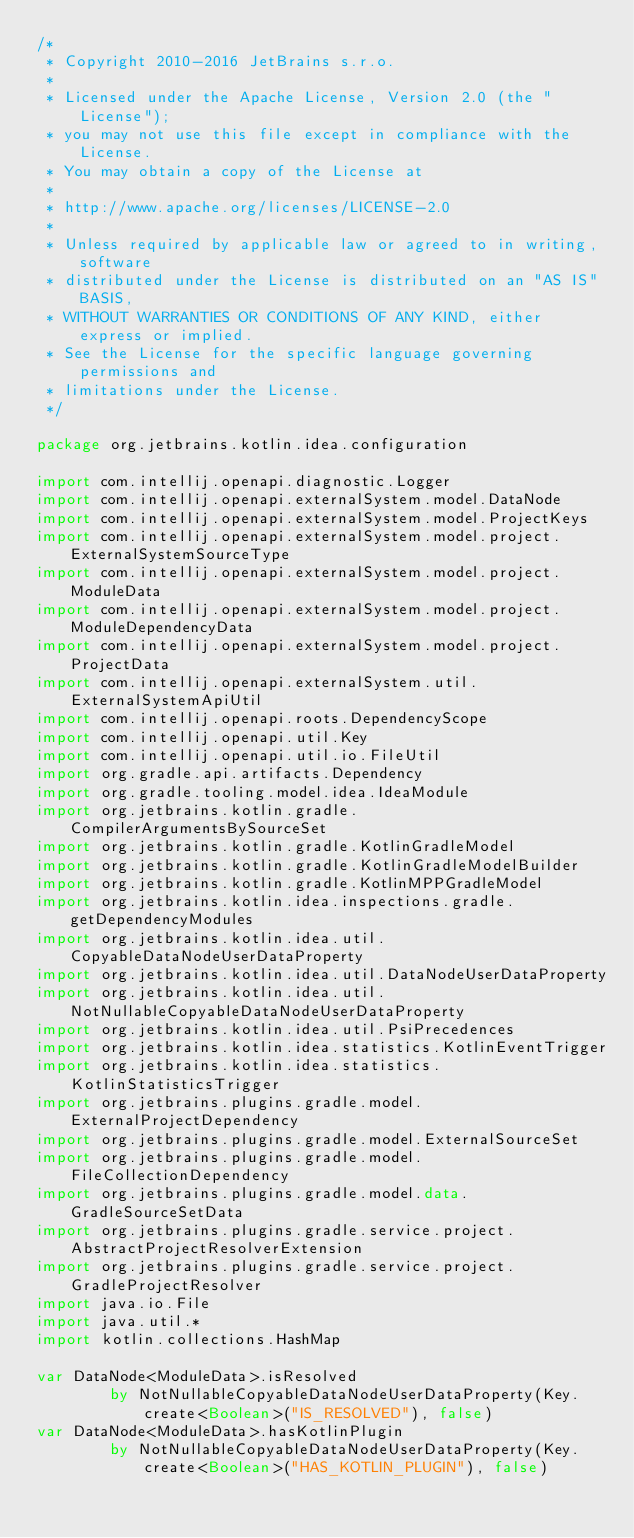Convert code to text. <code><loc_0><loc_0><loc_500><loc_500><_Kotlin_>/*
 * Copyright 2010-2016 JetBrains s.r.o.
 *
 * Licensed under the Apache License, Version 2.0 (the "License");
 * you may not use this file except in compliance with the License.
 * You may obtain a copy of the License at
 *
 * http://www.apache.org/licenses/LICENSE-2.0
 *
 * Unless required by applicable law or agreed to in writing, software
 * distributed under the License is distributed on an "AS IS" BASIS,
 * WITHOUT WARRANTIES OR CONDITIONS OF ANY KIND, either express or implied.
 * See the License for the specific language governing permissions and
 * limitations under the License.
 */

package org.jetbrains.kotlin.idea.configuration

import com.intellij.openapi.diagnostic.Logger
import com.intellij.openapi.externalSystem.model.DataNode
import com.intellij.openapi.externalSystem.model.ProjectKeys
import com.intellij.openapi.externalSystem.model.project.ExternalSystemSourceType
import com.intellij.openapi.externalSystem.model.project.ModuleData
import com.intellij.openapi.externalSystem.model.project.ModuleDependencyData
import com.intellij.openapi.externalSystem.model.project.ProjectData
import com.intellij.openapi.externalSystem.util.ExternalSystemApiUtil
import com.intellij.openapi.roots.DependencyScope
import com.intellij.openapi.util.Key
import com.intellij.openapi.util.io.FileUtil
import org.gradle.api.artifacts.Dependency
import org.gradle.tooling.model.idea.IdeaModule
import org.jetbrains.kotlin.gradle.CompilerArgumentsBySourceSet
import org.jetbrains.kotlin.gradle.KotlinGradleModel
import org.jetbrains.kotlin.gradle.KotlinGradleModelBuilder
import org.jetbrains.kotlin.gradle.KotlinMPPGradleModel
import org.jetbrains.kotlin.idea.inspections.gradle.getDependencyModules
import org.jetbrains.kotlin.idea.util.CopyableDataNodeUserDataProperty
import org.jetbrains.kotlin.idea.util.DataNodeUserDataProperty
import org.jetbrains.kotlin.idea.util.NotNullableCopyableDataNodeUserDataProperty
import org.jetbrains.kotlin.idea.util.PsiPrecedences
import org.jetbrains.kotlin.idea.statistics.KotlinEventTrigger
import org.jetbrains.kotlin.idea.statistics.KotlinStatisticsTrigger
import org.jetbrains.plugins.gradle.model.ExternalProjectDependency
import org.jetbrains.plugins.gradle.model.ExternalSourceSet
import org.jetbrains.plugins.gradle.model.FileCollectionDependency
import org.jetbrains.plugins.gradle.model.data.GradleSourceSetData
import org.jetbrains.plugins.gradle.service.project.AbstractProjectResolverExtension
import org.jetbrains.plugins.gradle.service.project.GradleProjectResolver
import java.io.File
import java.util.*
import kotlin.collections.HashMap

var DataNode<ModuleData>.isResolved
        by NotNullableCopyableDataNodeUserDataProperty(Key.create<Boolean>("IS_RESOLVED"), false)
var DataNode<ModuleData>.hasKotlinPlugin
        by NotNullableCopyableDataNodeUserDataProperty(Key.create<Boolean>("HAS_KOTLIN_PLUGIN"), false)</code> 